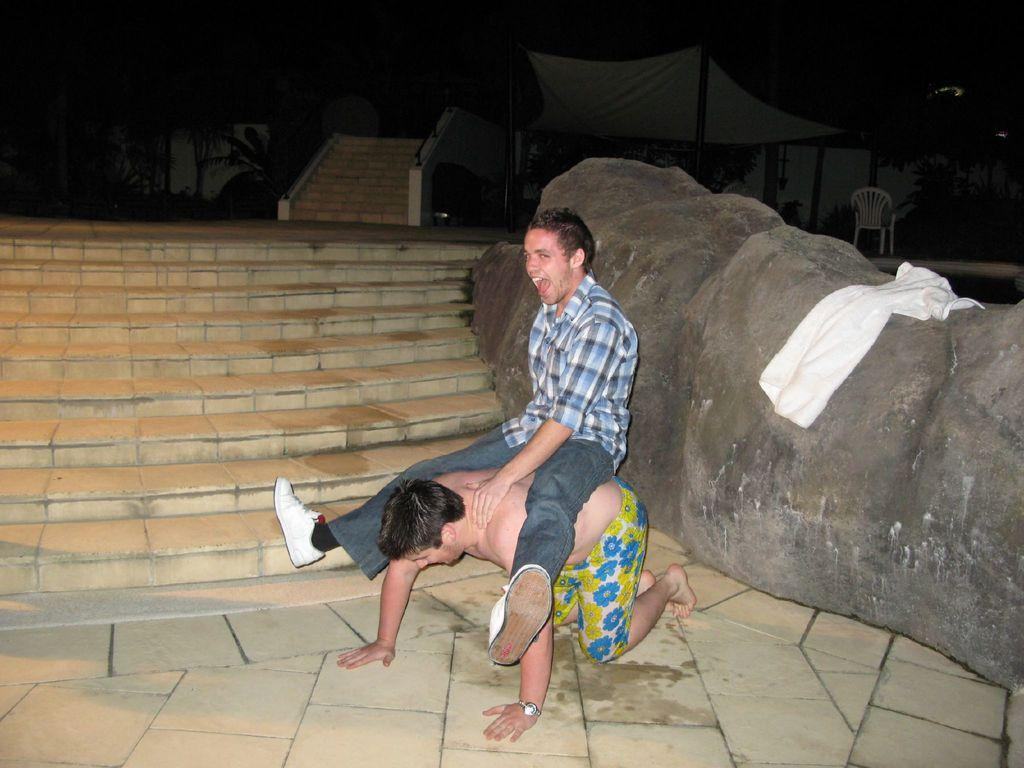What is happening between the two men in the image? There is a man sitting on another man in the image. What architectural feature can be seen in the image? There are stairs visible in the image. What object is placed on a rock in the image? There is a towel on a rock in the image. What type of vegetation is present in the image? Trees are present in the image. What type of furniture is visible in the image? There is a chair in the image. What structure might be visible in the background of the image? There appears to be a tent in the background of the image. What grade is the building in the image? There is no building present in the image, so it is not possible to determine its grade. 